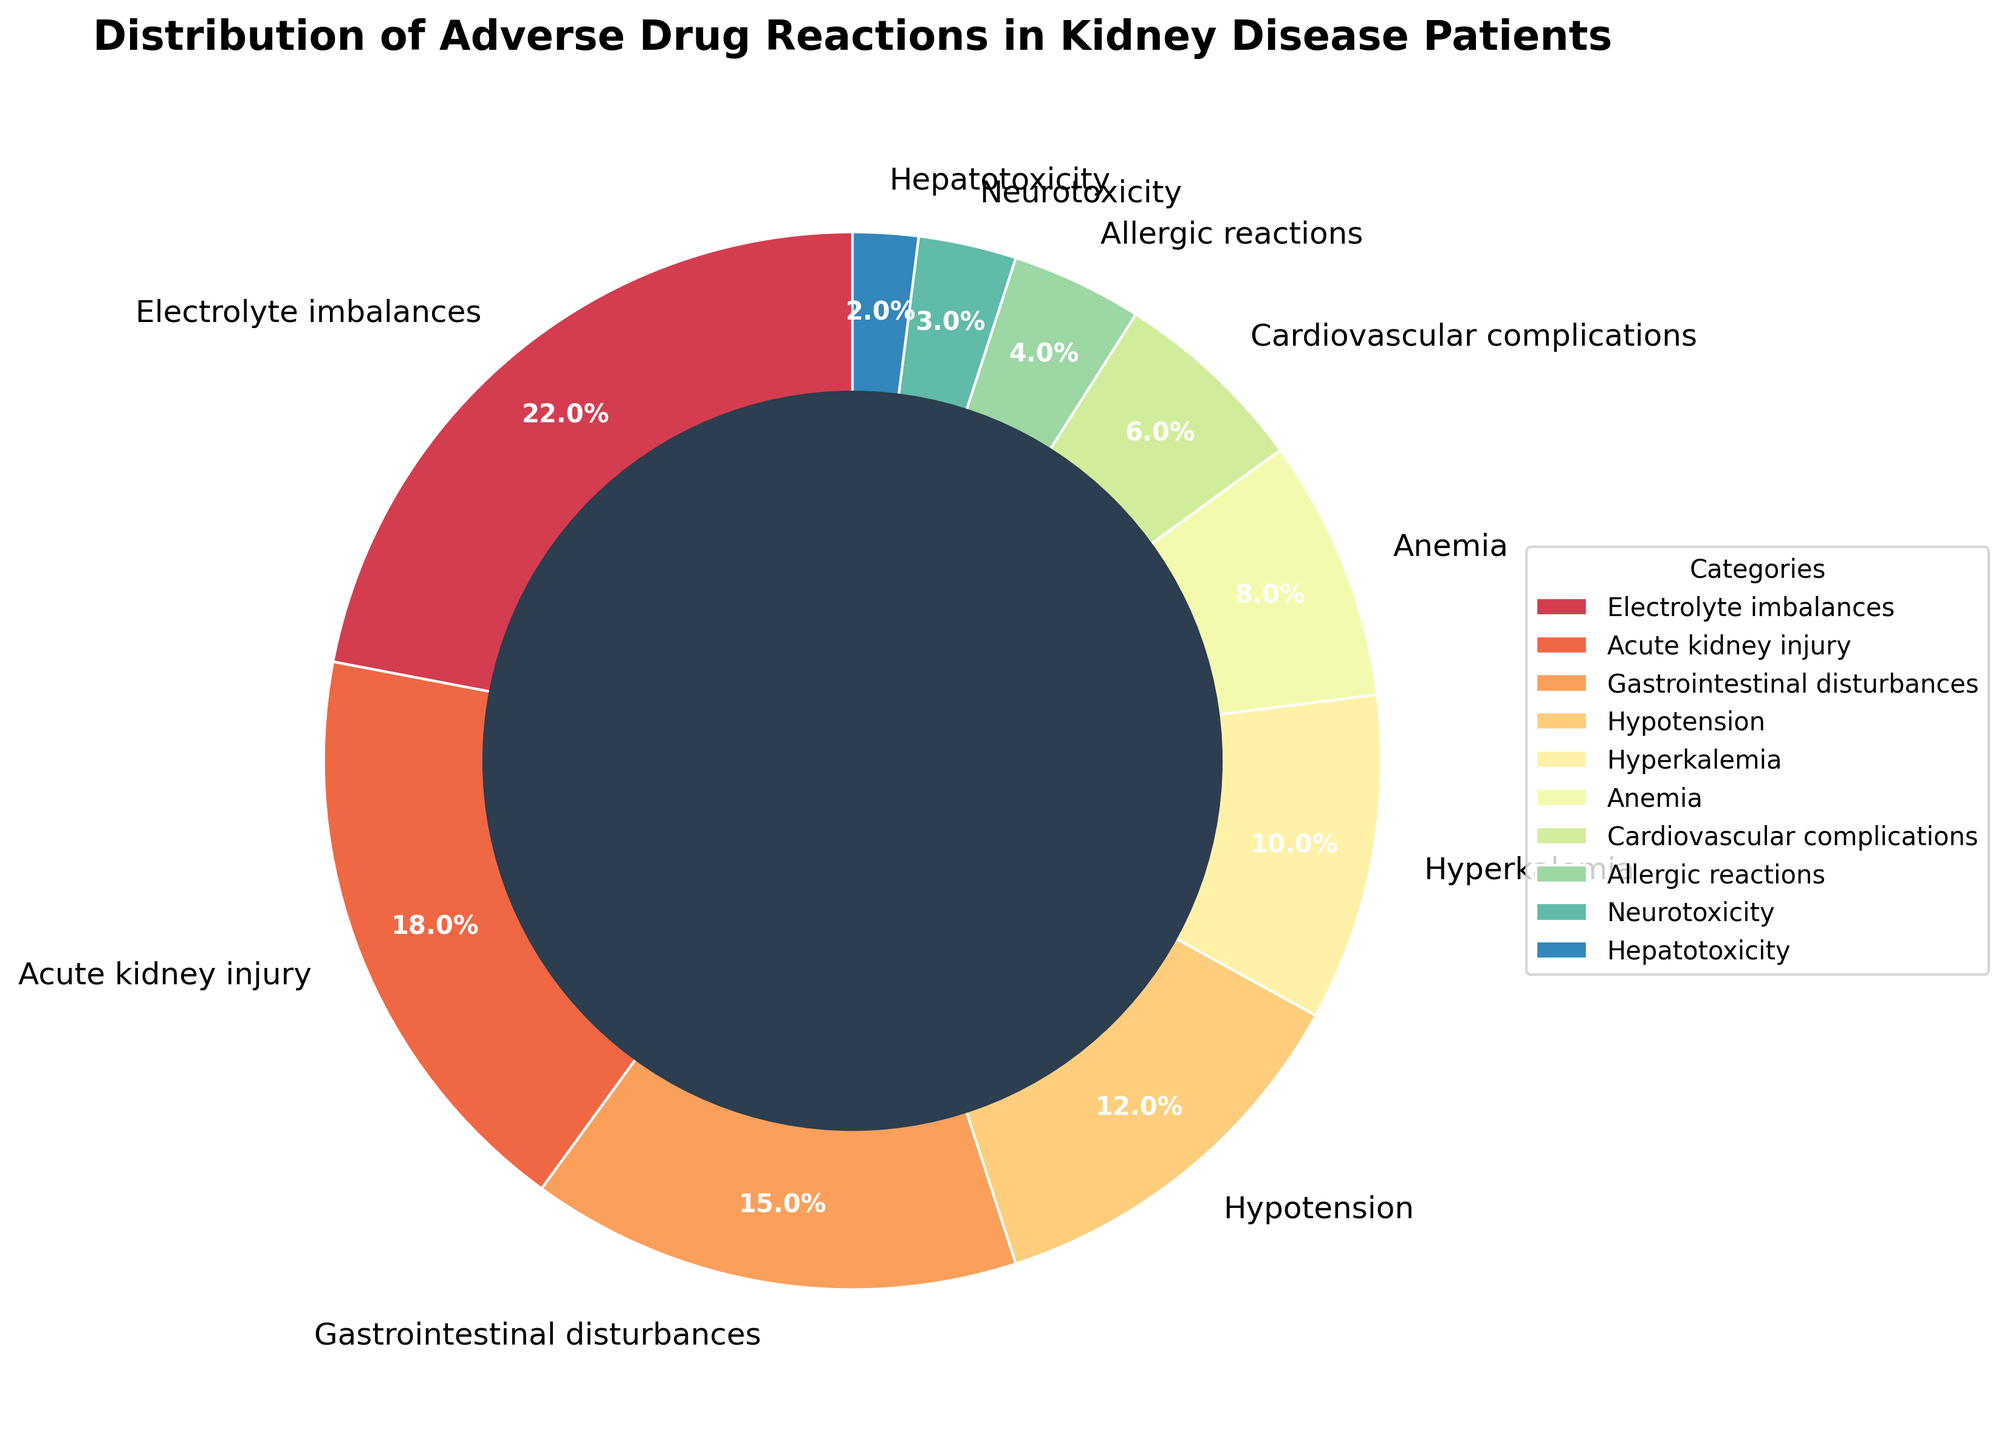What percentage of reported adverse drug reactions are electrolyte imbalances? Find the segment labeled "Electrolyte imbalances" in the pie chart, which shows 22%
Answer: 22% How does the percentage of Acute Kidney Injury compare to Gastrointestinal Disturbances? Find the segment labeled "Acute kidney injury," which shows 18%, and "Gastrointestinal disturbances," which shows 15%. Compare these percentages: 18% is greater than 15%
Answer: Acute kidney injury is higher What is the total percentage of cardiovascular complications and hypotension combined? Find the segments labeled "Cardiovascular complications" (6%) and "Hypotension" (12%). Add these percentages: 6% + 12% = 18%
Answer: 18% Which category has the smallest percentage, and what is it? Find the smallest segment in the pie chart, which is labeled "Hepatotoxicity". The percentage is 2%
Answer: Hepatotoxicity, 2% Out of the reported adverse drug reactions, which category falls into the middle range in terms of percentage, and what's its value? Order the segments by percentage and find the middle value. The middle one is labeled "Hypotension" with 12%.
Answer: Hypotension, 12% What's the combined percentage for all adverse drug reaction categories that are below 10%? Add the percentages of categories: Hyperkalemia (10%), Anemia (8%), Cardiovascular complications (6%), Allergic reactions (4%), Neurotoxicity (3%), Hepatotoxicity (2%). 10% + 8% + 6% + 4% + 3% + 2% = 33%
Answer: 33% What can you say about the categories of adverse drug reactions that are represented by the larger segments of the pie chart? The pie chart shows that the larger segments represent Electrolyte imbalances (22%), Acute kidney injury (18%), and Gastrointestinal disturbances (15%). These categories likely represent the most common adverse reactions in kidney disease patients.
Answer: These categories are most common How does the percentage of Anemia compare to Hyperkalemia? Find the segments labeled "Anemia" (8%) and "Hyperkalemia" (10%). Compare these percentages: 8% is less than 10%
Answer: Anemia is smaller Is the combined percentage of Electrolyte imbalances and Acute kidney injury greater than 40%? Add the percentages of Electrolyte imbalances (22%) and Acute kidney injury (18%): 22% + 18% = 40%. Since 40% is not greater than 40%, the answer is no.
Answer: No Which category is represented in blue in the pie chart? Refer to the color assigned to each category segment in the pie chart. The segment colored blue represents "Acute kidney injury"
Answer: Acute kidney injury 